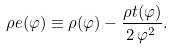<formula> <loc_0><loc_0><loc_500><loc_500>\rho e ( \varphi ) & \equiv \rho ( \varphi ) - \frac { \rho t ( \varphi ) } { 2 \, \varphi ^ { 2 } \, } .</formula> 